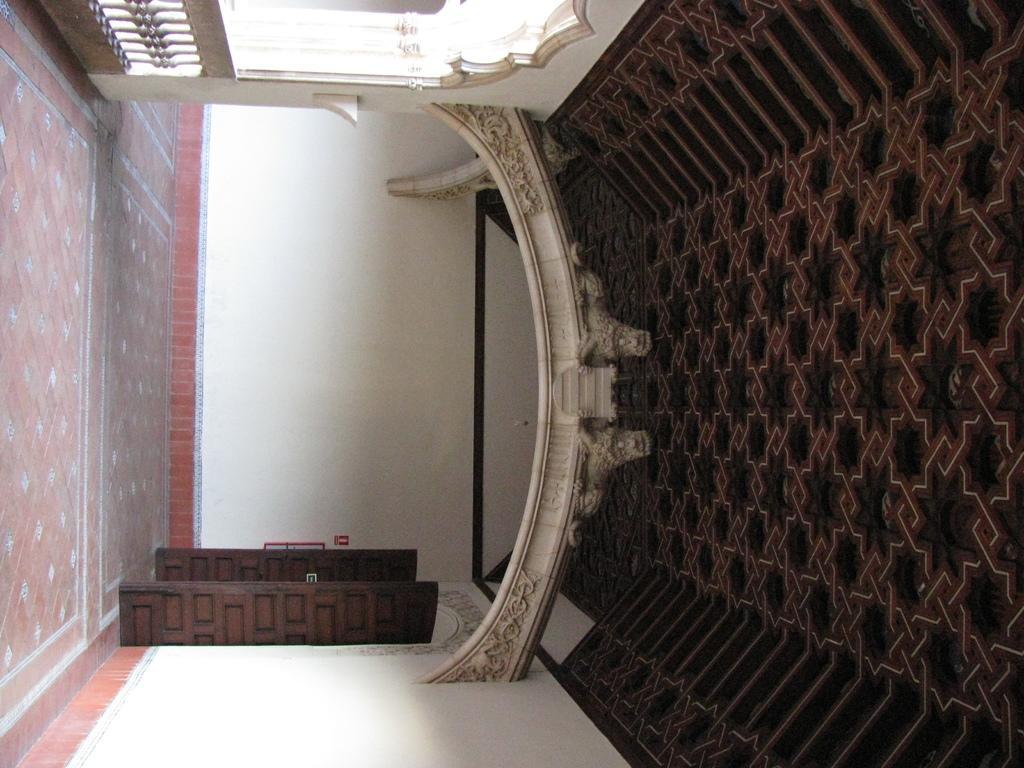In one or two sentences, can you explain what this image depicts? This is a rotated image. This is the floor. This is the ceiling. This is a door. This is boundary. 